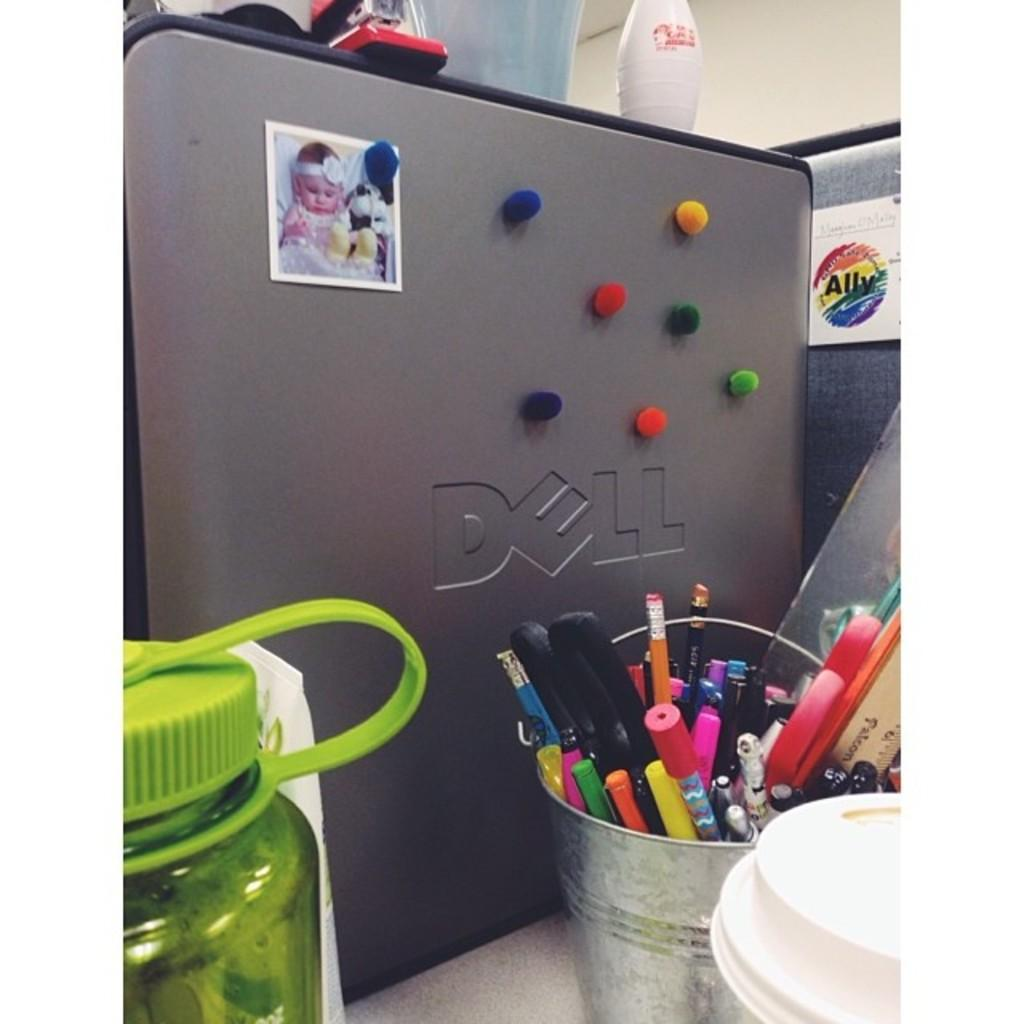<image>
Summarize the visual content of the image. A Dell computer monitor has been decorated with pom pom balls and a baby picture 